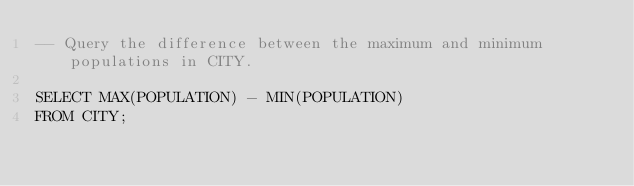Convert code to text. <code><loc_0><loc_0><loc_500><loc_500><_SQL_>-- Query the difference between the maximum and minimum populations in CITY.

SELECT MAX(POPULATION) - MIN(POPULATION)
FROM CITY;</code> 